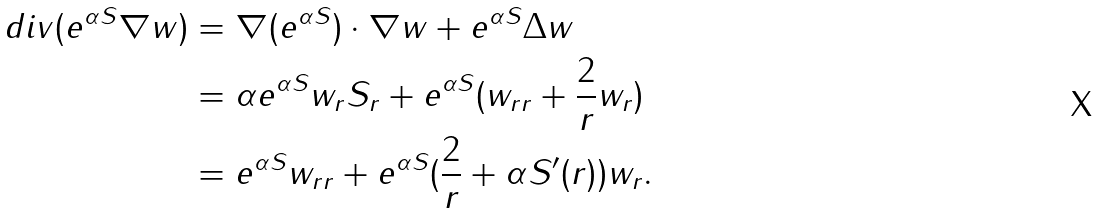<formula> <loc_0><loc_0><loc_500><loc_500>d i v ( e ^ { \alpha S } \nabla w ) & = \nabla ( e ^ { \alpha S } ) \cdot \nabla w + e ^ { \alpha S } \Delta w \\ & = \alpha e ^ { \alpha S } w _ { r } S _ { r } + e ^ { \alpha S } ( w _ { r r } + \frac { 2 } { r } w _ { r } ) \\ & = e ^ { \alpha S } w _ { r r } + e ^ { \alpha S } ( \frac { 2 } { r } + \alpha S ^ { \prime } ( r ) ) w _ { r } .</formula> 